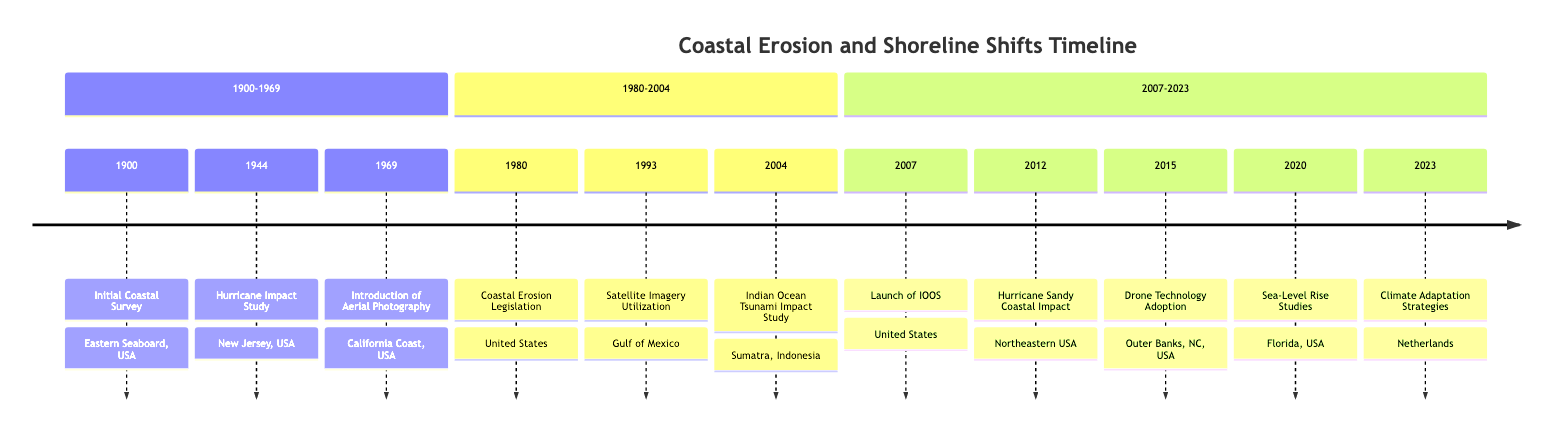What year did the Initial Coastal Survey occur? The timeline indicates that the Initial Coastal Survey took place in the year 1900 as the first entry in the timeline.
Answer: 1900 What location is associated with the 2004 Indian Ocean Tsunami Impact Study? According to the timeline, the 2004 Indian Ocean Tsunami Impact Study is associated with Sumatra, Indonesia, as specified in the details of that event.
Answer: Sumatra, Indonesia How many significant events are noted between 1980 and 2004? In the section of the timeline covering 1980 to 2004, there are three significant events listed: the Coastal Erosion Legislation in 1980, Satellite Imagery Utilization in 1993, and the Indian Ocean Tsunami Impact Study in 2004.
Answer: 3 What event marks the introduction of aerial technology for coastline mapping? The timeline shows that the introduction of aerial photography for coastline mapping occurred in 1969, making it a significant milestone in the methodology used for mapping coastlines.
Answer: Introduction of Aerial Photography Which event occurred immediately before Hurricane Sandy's impact in 2012? Reviewing the timeline, the event that occurred immediately before Hurricane Sandy's impact in 2012 is the launch of The Integrated Ocean Observing System (IOOS) in 2007.
Answer: Launch of IOOS Identify the event in 2020 related to sea-level studies. The timeline specifies that in 2020, there is a focus on intensified studies regarding the impact of sea-level rise on coastal erosion, making it clear that this is the event related to sea-level studies.
Answer: Sea-Level Rise Studies What was the response focus of the 1980 Coastal Erosion Legislation? The timeline indicates that the focus of the 1980 Coastal Erosion Legislation was to mitigate shoreline development impacts, serving as a governmental response to coastal erosion.
Answer: Mitigate shoreline development impacts List the technological advancement noted in 2015 related to coastline monitoring. The advancements in 2015 regarding coastline monitoring involved the adoption of drone technology for high-resolution mapping and real-time monitoring as highlighted in that year’s event.
Answer: Drone Technology Adoption What year marks the implementation of Climate Adaptation Strategies? According to the timeline, the year 2023 marks the implementation of Climate Adaptation Strategies, demonstrating a proactive approach to coastal erosion management.
Answer: 2023 What analysis followed the 1944 Great Atlantic Hurricane? The timeline mentions an analysis specifically focused on coastal erosion following the 1944 Great Atlantic Hurricane, denoting an event centered around the impacts of that hurricane.
Answer: Hurricane Impact Study 